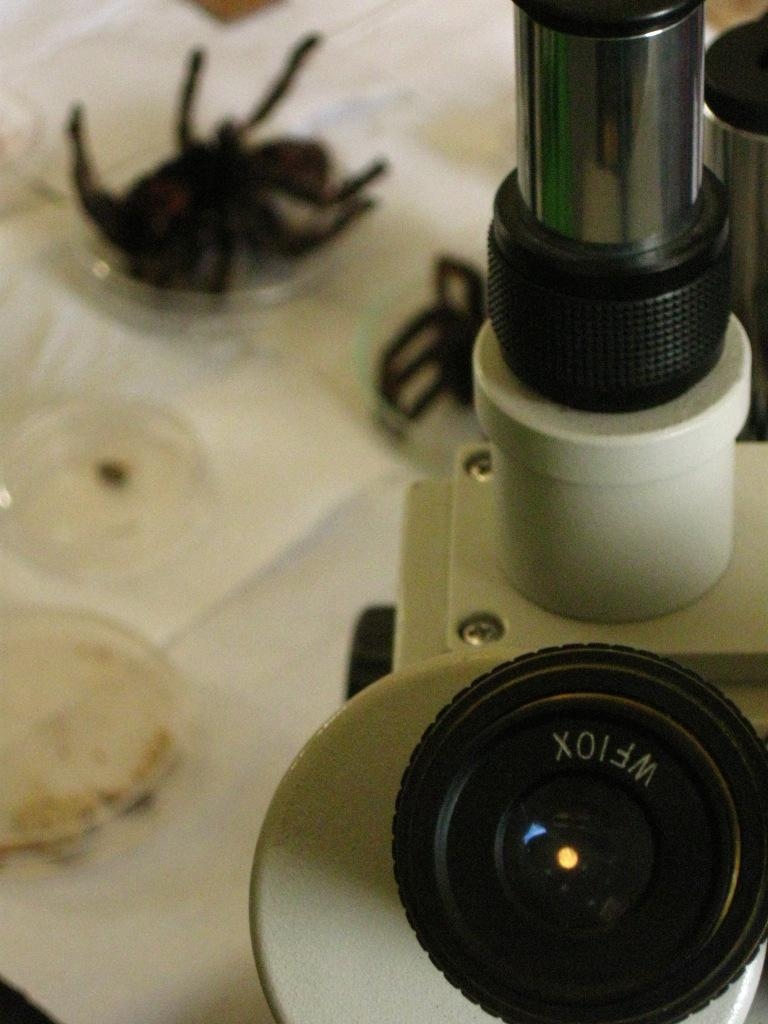What is the main object in the image? There is a microscope in the image. What can be seen through the microscope? The image does not show what is visible through the microscope, only the microscope itself. Where are the objects placed in the image? The objects are on a white surface. What type of food is being prepared on the white surface in the image? There is no food or preparation visible in the image; it only shows a microscope and objects on a white surface. 